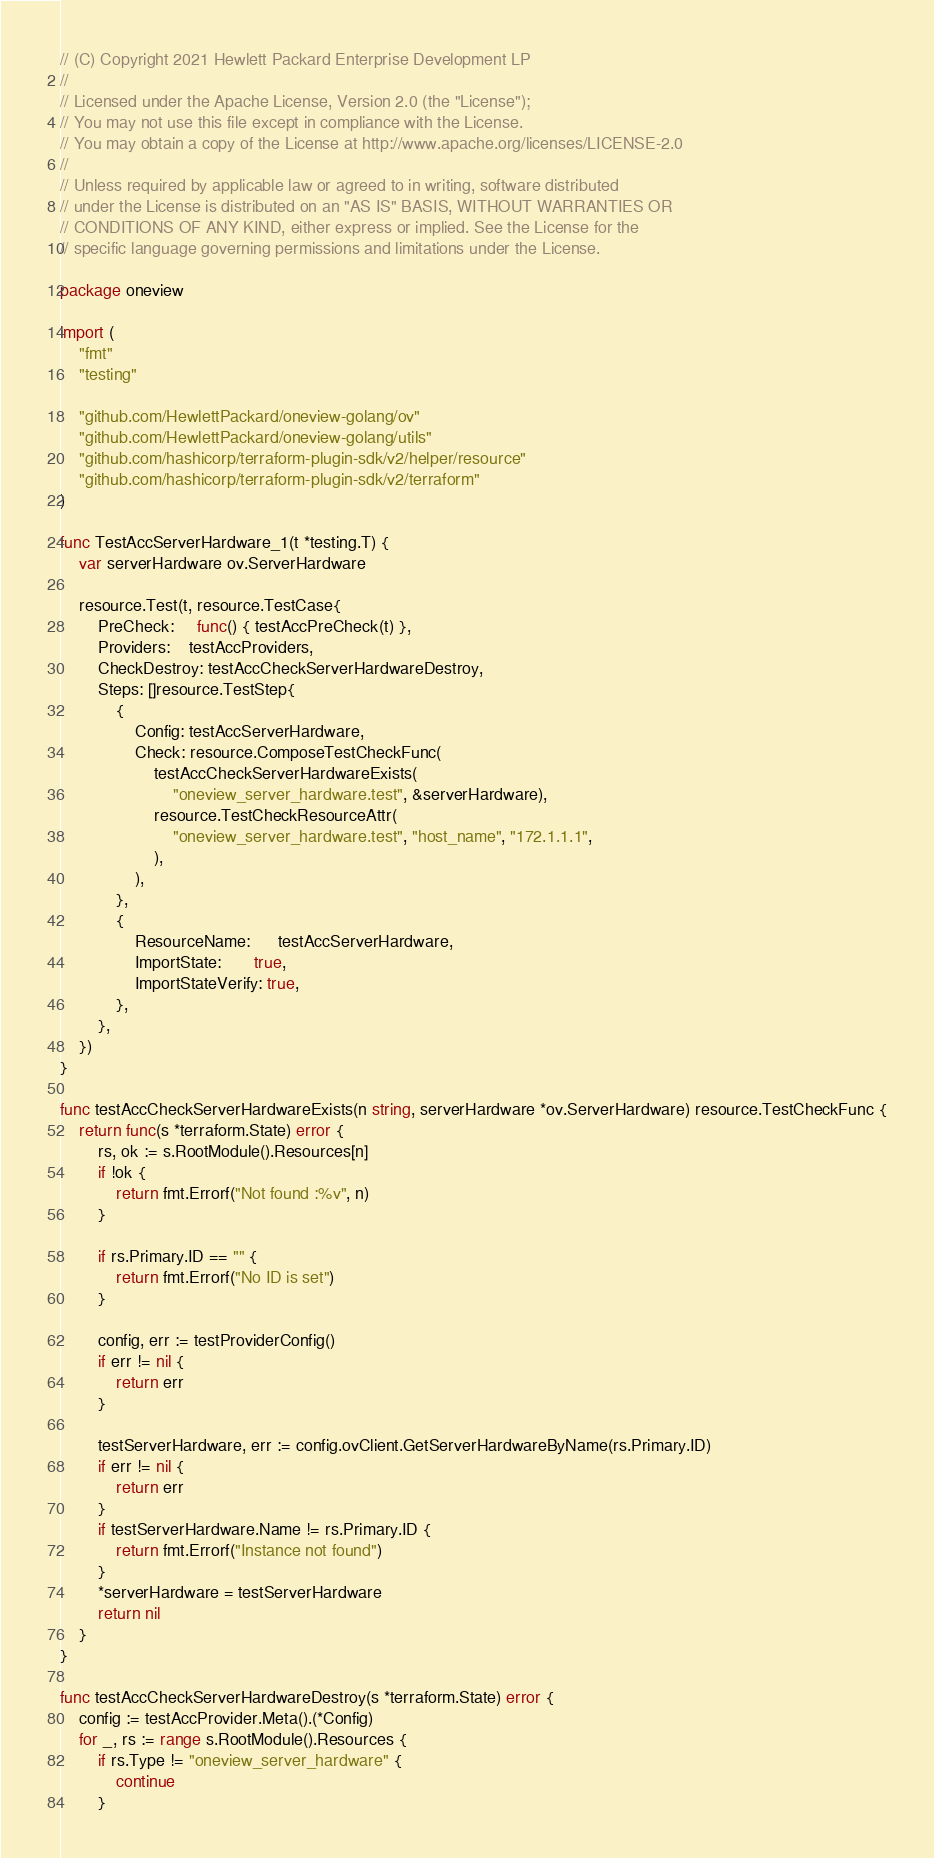Convert code to text. <code><loc_0><loc_0><loc_500><loc_500><_Go_>// (C) Copyright 2021 Hewlett Packard Enterprise Development LP
//
// Licensed under the Apache License, Version 2.0 (the "License");
// You may not use this file except in compliance with the License.
// You may obtain a copy of the License at http://www.apache.org/licenses/LICENSE-2.0
//
// Unless required by applicable law or agreed to in writing, software distributed
// under the License is distributed on an "AS IS" BASIS, WITHOUT WARRANTIES OR
// CONDITIONS OF ANY KIND, either express or implied. See the License for the
// specific language governing permissions and limitations under the License.

package oneview

import (
	"fmt"
	"testing"

	"github.com/HewlettPackard/oneview-golang/ov"
	"github.com/HewlettPackard/oneview-golang/utils"
	"github.com/hashicorp/terraform-plugin-sdk/v2/helper/resource"
	"github.com/hashicorp/terraform-plugin-sdk/v2/terraform"
)

func TestAccServerHardware_1(t *testing.T) {
	var serverHardware ov.ServerHardware

	resource.Test(t, resource.TestCase{
		PreCheck:     func() { testAccPreCheck(t) },
		Providers:    testAccProviders,
		CheckDestroy: testAccCheckServerHardwareDestroy,
		Steps: []resource.TestStep{
			{
				Config: testAccServerHardware,
				Check: resource.ComposeTestCheckFunc(
					testAccCheckServerHardwareExists(
						"oneview_server_hardware.test", &serverHardware),
					resource.TestCheckResourceAttr(
						"oneview_server_hardware.test", "host_name", "172.1.1.1",
					),
				),
			},
			{
				ResourceName:      testAccServerHardware,
				ImportState:       true,
				ImportStateVerify: true,
			},
		},
	})
}

func testAccCheckServerHardwareExists(n string, serverHardware *ov.ServerHardware) resource.TestCheckFunc {
	return func(s *terraform.State) error {
		rs, ok := s.RootModule().Resources[n]
		if !ok {
			return fmt.Errorf("Not found :%v", n)
		}

		if rs.Primary.ID == "" {
			return fmt.Errorf("No ID is set")
		}

		config, err := testProviderConfig()
		if err != nil {
			return err
		}

		testServerHardware, err := config.ovClient.GetServerHardwareByName(rs.Primary.ID)
		if err != nil {
			return err
		}
		if testServerHardware.Name != rs.Primary.ID {
			return fmt.Errorf("Instance not found")
		}
		*serverHardware = testServerHardware
		return nil
	}
}

func testAccCheckServerHardwareDestroy(s *terraform.State) error {
	config := testAccProvider.Meta().(*Config)
	for _, rs := range s.RootModule().Resources {
		if rs.Type != "oneview_server_hardware" {
			continue
		}
</code> 